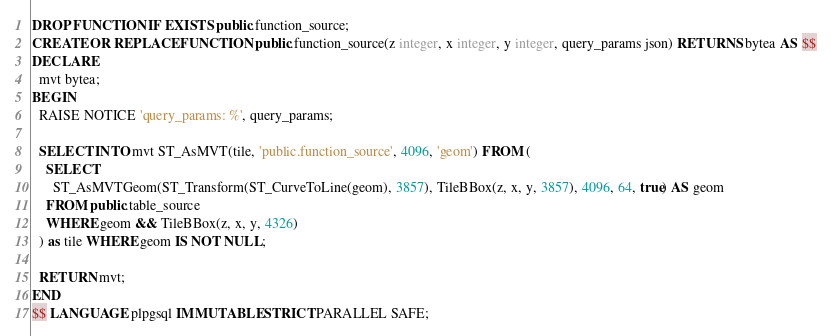<code> <loc_0><loc_0><loc_500><loc_500><_SQL_>DROP FUNCTION IF EXISTS public.function_source;
CREATE OR REPLACE FUNCTION public.function_source(z integer, x integer, y integer, query_params json) RETURNS bytea AS $$
DECLARE
  mvt bytea;
BEGIN
  RAISE NOTICE 'query_params: %', query_params;

  SELECT INTO mvt ST_AsMVT(tile, 'public.function_source', 4096, 'geom') FROM (
    SELECT
      ST_AsMVTGeom(ST_Transform(ST_CurveToLine(geom), 3857), TileBBox(z, x, y, 3857), 4096, 64, true) AS geom
    FROM public.table_source
    WHERE geom && TileBBox(z, x, y, 4326)
  ) as tile WHERE geom IS NOT NULL;

  RETURN mvt;
END
$$ LANGUAGE plpgsql IMMUTABLE STRICT PARALLEL SAFE;</code> 